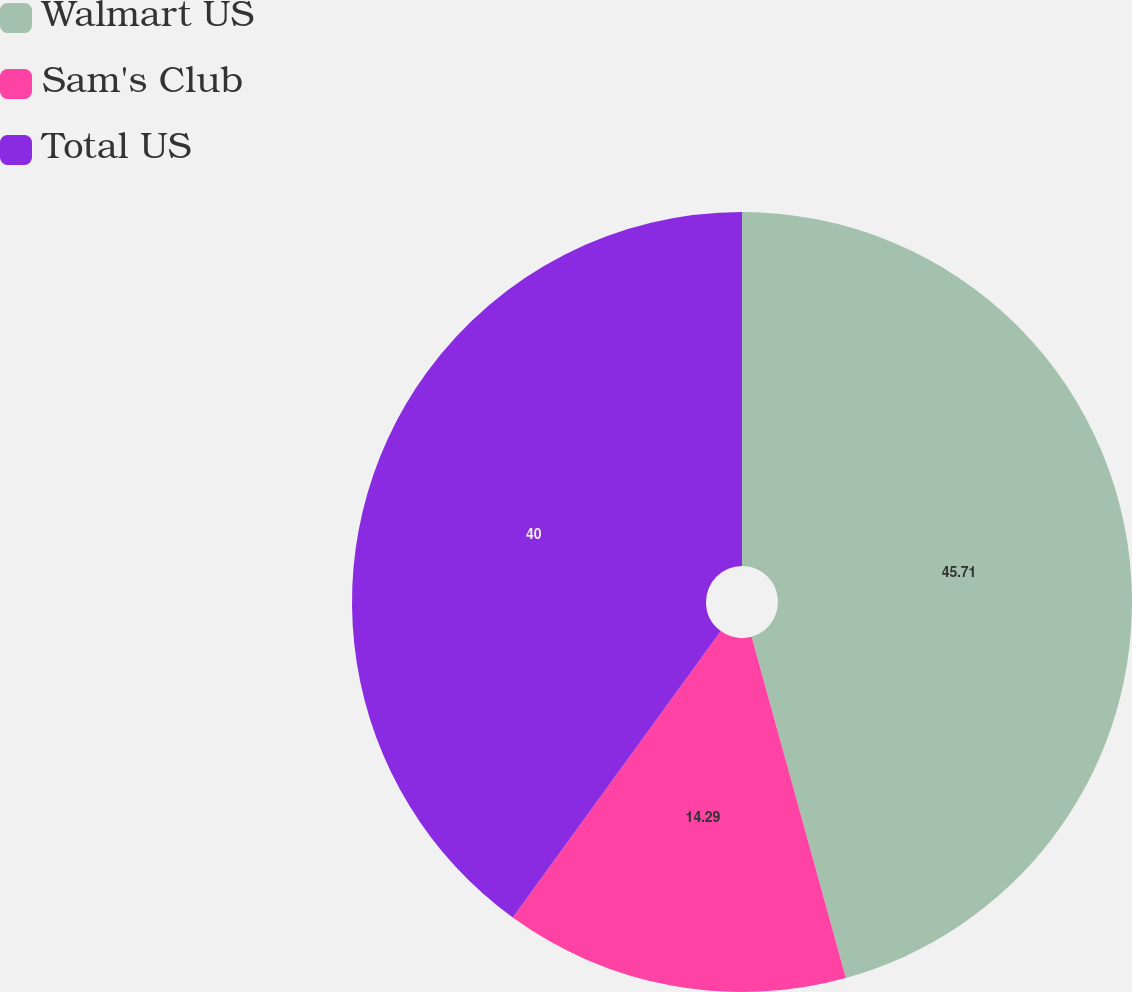Convert chart. <chart><loc_0><loc_0><loc_500><loc_500><pie_chart><fcel>Walmart US<fcel>Sam's Club<fcel>Total US<nl><fcel>45.71%<fcel>14.29%<fcel>40.0%<nl></chart> 